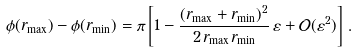Convert formula to latex. <formula><loc_0><loc_0><loc_500><loc_500>\phi ( r _ { \max } ) - \phi ( r _ { \min } ) = \pi \left [ 1 - \frac { ( r _ { \max } + r _ { \min } ) ^ { 2 } } { 2 \, r _ { \max } r _ { \min } } \, \varepsilon + \mathcal { O } ( \varepsilon ^ { 2 } ) \right ] \, .</formula> 